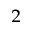Convert formula to latex. <formula><loc_0><loc_0><loc_500><loc_500>_ { 2 }</formula> 